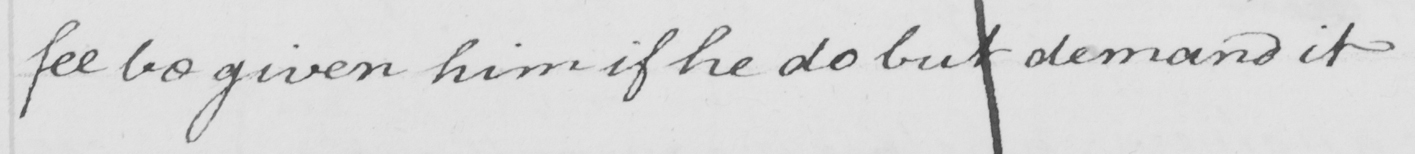Can you read and transcribe this handwriting? fee be given him if he do but demand it . 